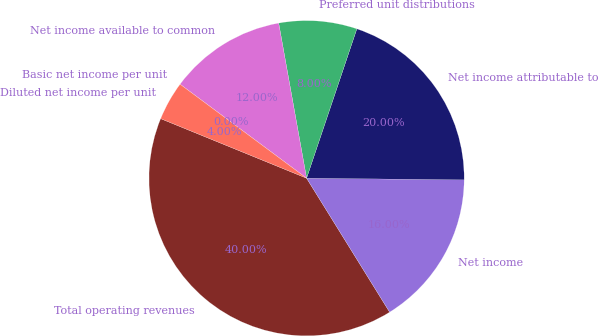Convert chart to OTSL. <chart><loc_0><loc_0><loc_500><loc_500><pie_chart><fcel>Total operating revenues<fcel>Net income<fcel>Net income attributable to<fcel>Preferred unit distributions<fcel>Net income available to common<fcel>Basic net income per unit<fcel>Diluted net income per unit<nl><fcel>40.0%<fcel>16.0%<fcel>20.0%<fcel>8.0%<fcel>12.0%<fcel>0.0%<fcel>4.0%<nl></chart> 